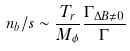<formula> <loc_0><loc_0><loc_500><loc_500>n _ { b } / s \sim \frac { T _ { r } } { M _ { \phi } } \frac { \Gamma _ { \Delta B \neq 0 } } { \Gamma }</formula> 